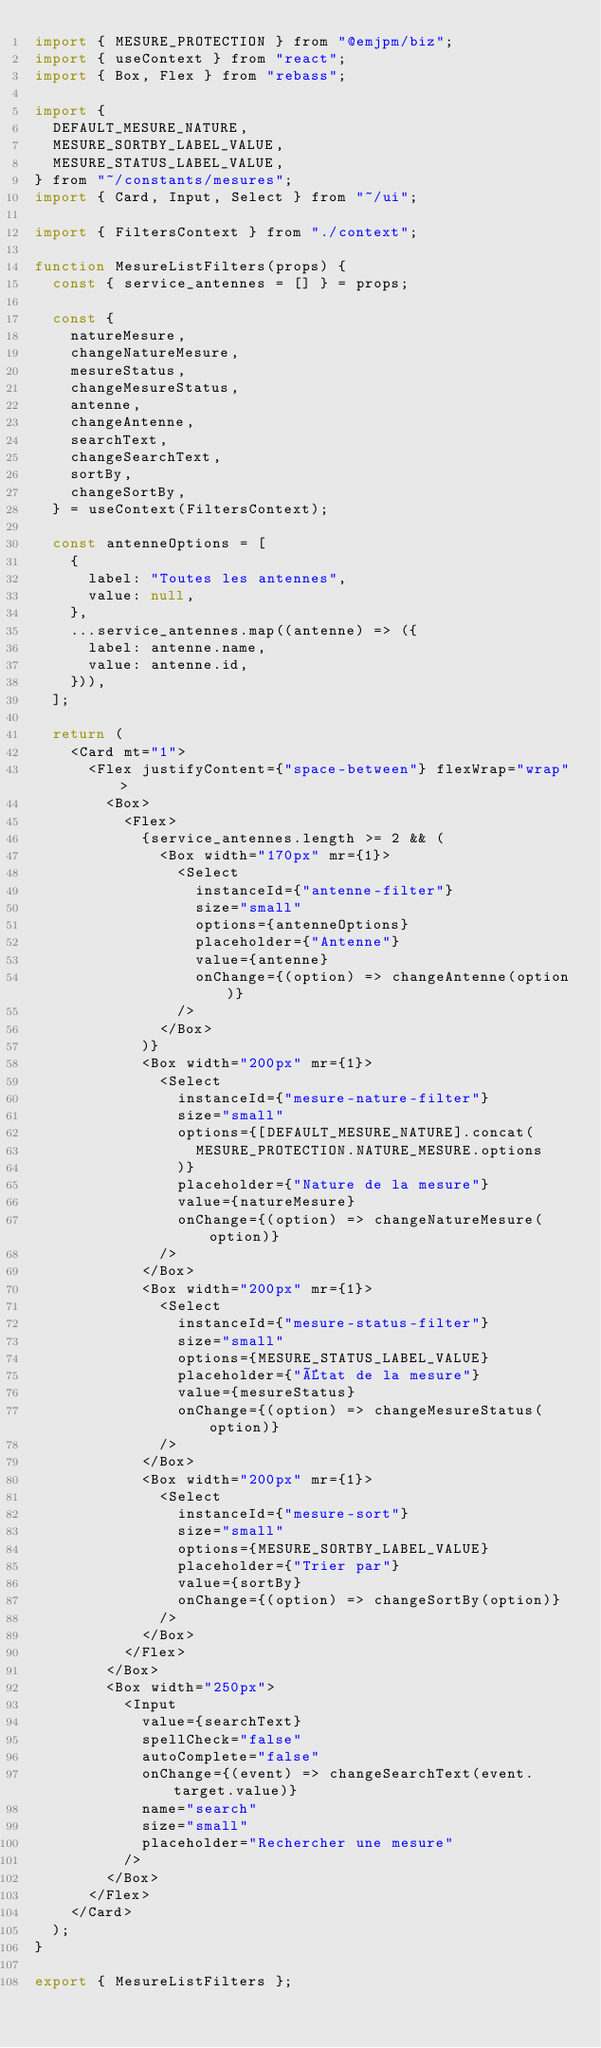<code> <loc_0><loc_0><loc_500><loc_500><_JavaScript_>import { MESURE_PROTECTION } from "@emjpm/biz";
import { useContext } from "react";
import { Box, Flex } from "rebass";

import {
  DEFAULT_MESURE_NATURE,
  MESURE_SORTBY_LABEL_VALUE,
  MESURE_STATUS_LABEL_VALUE,
} from "~/constants/mesures";
import { Card, Input, Select } from "~/ui";

import { FiltersContext } from "./context";

function MesureListFilters(props) {
  const { service_antennes = [] } = props;

  const {
    natureMesure,
    changeNatureMesure,
    mesureStatus,
    changeMesureStatus,
    antenne,
    changeAntenne,
    searchText,
    changeSearchText,
    sortBy,
    changeSortBy,
  } = useContext(FiltersContext);

  const antenneOptions = [
    {
      label: "Toutes les antennes",
      value: null,
    },
    ...service_antennes.map((antenne) => ({
      label: antenne.name,
      value: antenne.id,
    })),
  ];

  return (
    <Card mt="1">
      <Flex justifyContent={"space-between"} flexWrap="wrap">
        <Box>
          <Flex>
            {service_antennes.length >= 2 && (
              <Box width="170px" mr={1}>
                <Select
                  instanceId={"antenne-filter"}
                  size="small"
                  options={antenneOptions}
                  placeholder={"Antenne"}
                  value={antenne}
                  onChange={(option) => changeAntenne(option)}
                />
              </Box>
            )}
            <Box width="200px" mr={1}>
              <Select
                instanceId={"mesure-nature-filter"}
                size="small"
                options={[DEFAULT_MESURE_NATURE].concat(
                  MESURE_PROTECTION.NATURE_MESURE.options
                )}
                placeholder={"Nature de la mesure"}
                value={natureMesure}
                onChange={(option) => changeNatureMesure(option)}
              />
            </Box>
            <Box width="200px" mr={1}>
              <Select
                instanceId={"mesure-status-filter"}
                size="small"
                options={MESURE_STATUS_LABEL_VALUE}
                placeholder={"État de la mesure"}
                value={mesureStatus}
                onChange={(option) => changeMesureStatus(option)}
              />
            </Box>
            <Box width="200px" mr={1}>
              <Select
                instanceId={"mesure-sort"}
                size="small"
                options={MESURE_SORTBY_LABEL_VALUE}
                placeholder={"Trier par"}
                value={sortBy}
                onChange={(option) => changeSortBy(option)}
              />
            </Box>
          </Flex>
        </Box>
        <Box width="250px">
          <Input
            value={searchText}
            spellCheck="false"
            autoComplete="false"
            onChange={(event) => changeSearchText(event.target.value)}
            name="search"
            size="small"
            placeholder="Rechercher une mesure"
          />
        </Box>
      </Flex>
    </Card>
  );
}

export { MesureListFilters };
</code> 